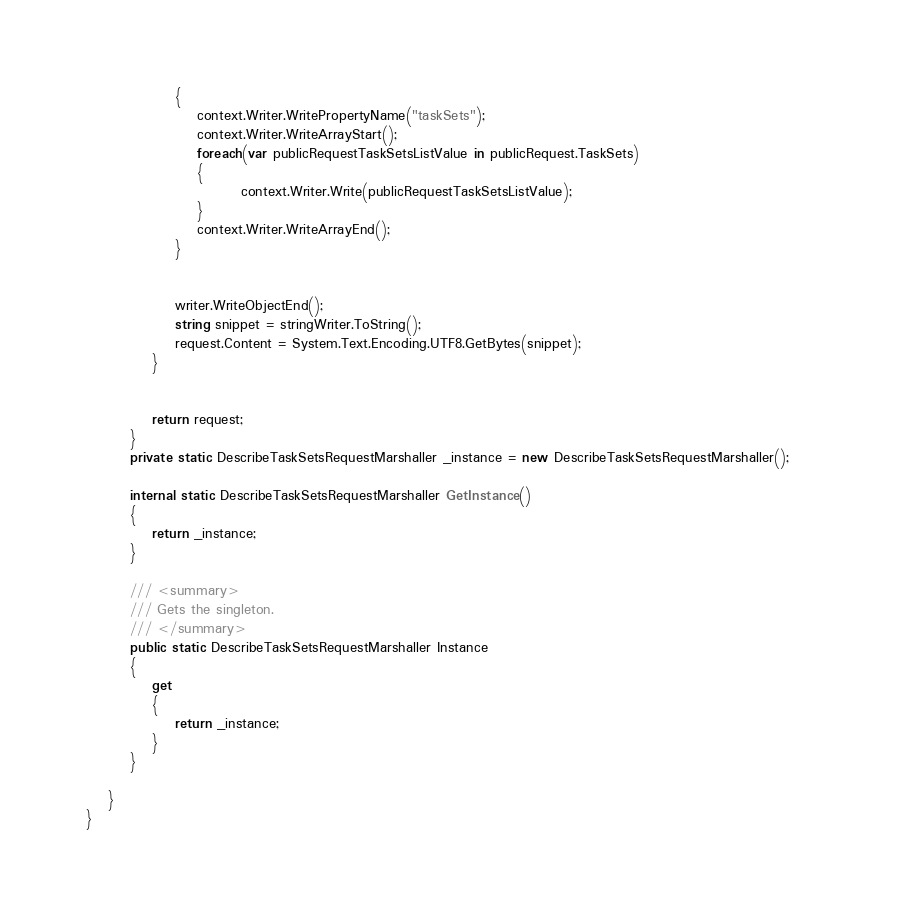Convert code to text. <code><loc_0><loc_0><loc_500><loc_500><_C#_>                {
                    context.Writer.WritePropertyName("taskSets");
                    context.Writer.WriteArrayStart();
                    foreach(var publicRequestTaskSetsListValue in publicRequest.TaskSets)
                    {
                            context.Writer.Write(publicRequestTaskSetsListValue);
                    }
                    context.Writer.WriteArrayEnd();
                }

        
                writer.WriteObjectEnd();
                string snippet = stringWriter.ToString();
                request.Content = System.Text.Encoding.UTF8.GetBytes(snippet);
            }


            return request;
        }
        private static DescribeTaskSetsRequestMarshaller _instance = new DescribeTaskSetsRequestMarshaller();        

        internal static DescribeTaskSetsRequestMarshaller GetInstance()
        {
            return _instance;
        }

        /// <summary>
        /// Gets the singleton.
        /// </summary>  
        public static DescribeTaskSetsRequestMarshaller Instance
        {
            get
            {
                return _instance;
            }
        }

    }
}</code> 